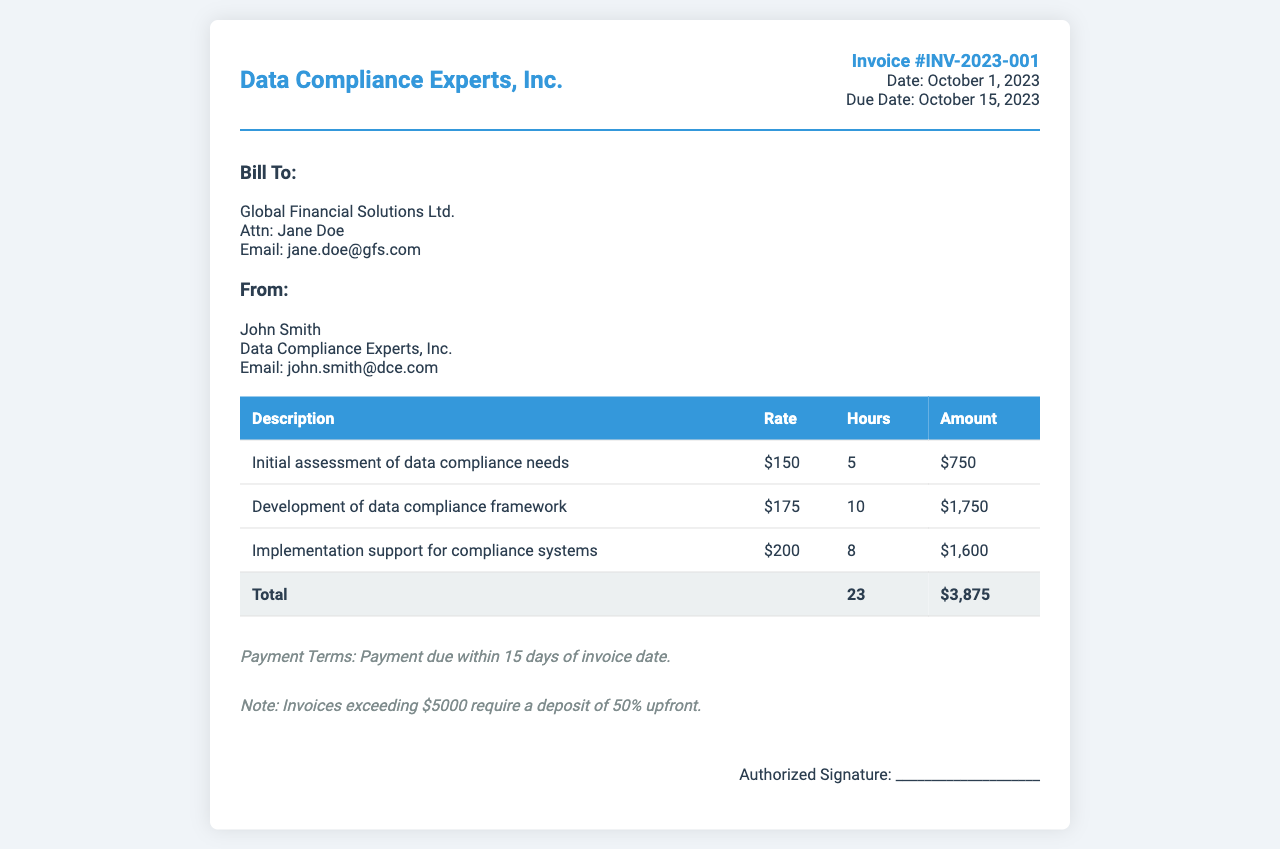What is the invoice number? The invoice number is explicitly mentioned in the document as "Invoice #INV-2023-001."
Answer: Invoice #INV-2023-001 What is the total amount billed? The total amount is the sum of all itemized services, which totals $3,875.
Answer: $3,875 Who is the client? The client's name and company are provided in the billing section as "Global Financial Solutions Ltd."
Answer: Global Financial Solutions Ltd What is the hourly rate for implementation support? The document specifies that the hourly rate for implementation support for compliance systems is $200.
Answer: $200 How many hours were billed in total? The total hours are calculated from the individual services summed up, which is 23 hours.
Answer: 23 What is the payment due date? The payment due date is clearly stated in the document as "October 15, 2023."
Answer: October 15, 2023 What is the note regarding invoices exceeding $5000? The note states that invoices exceeding $5000 require a deposit of 50% upfront.
Answer: A deposit of 50% upfront Who is the consultant? The consultant's name is provided in the document as "John Smith."
Answer: John Smith What is the date of the invoice? The date of the invoice is mentioned as "October 1, 2023."
Answer: October 1, 2023 